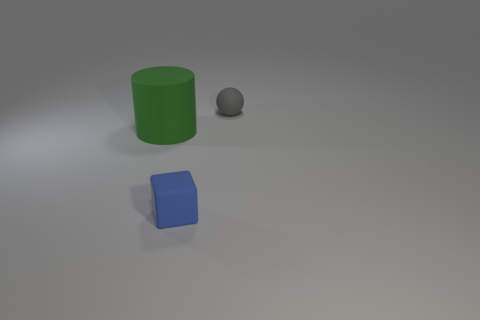Add 2 blue objects. How many objects exist? 5 Subtract 1 cylinders. How many cylinders are left? 0 Subtract all tiny gray things. Subtract all blue objects. How many objects are left? 1 Add 2 large rubber things. How many large rubber things are left? 3 Add 2 large brown things. How many large brown things exist? 2 Subtract 0 brown cylinders. How many objects are left? 3 Subtract all cylinders. How many objects are left? 2 Subtract all purple blocks. Subtract all purple balls. How many blocks are left? 1 